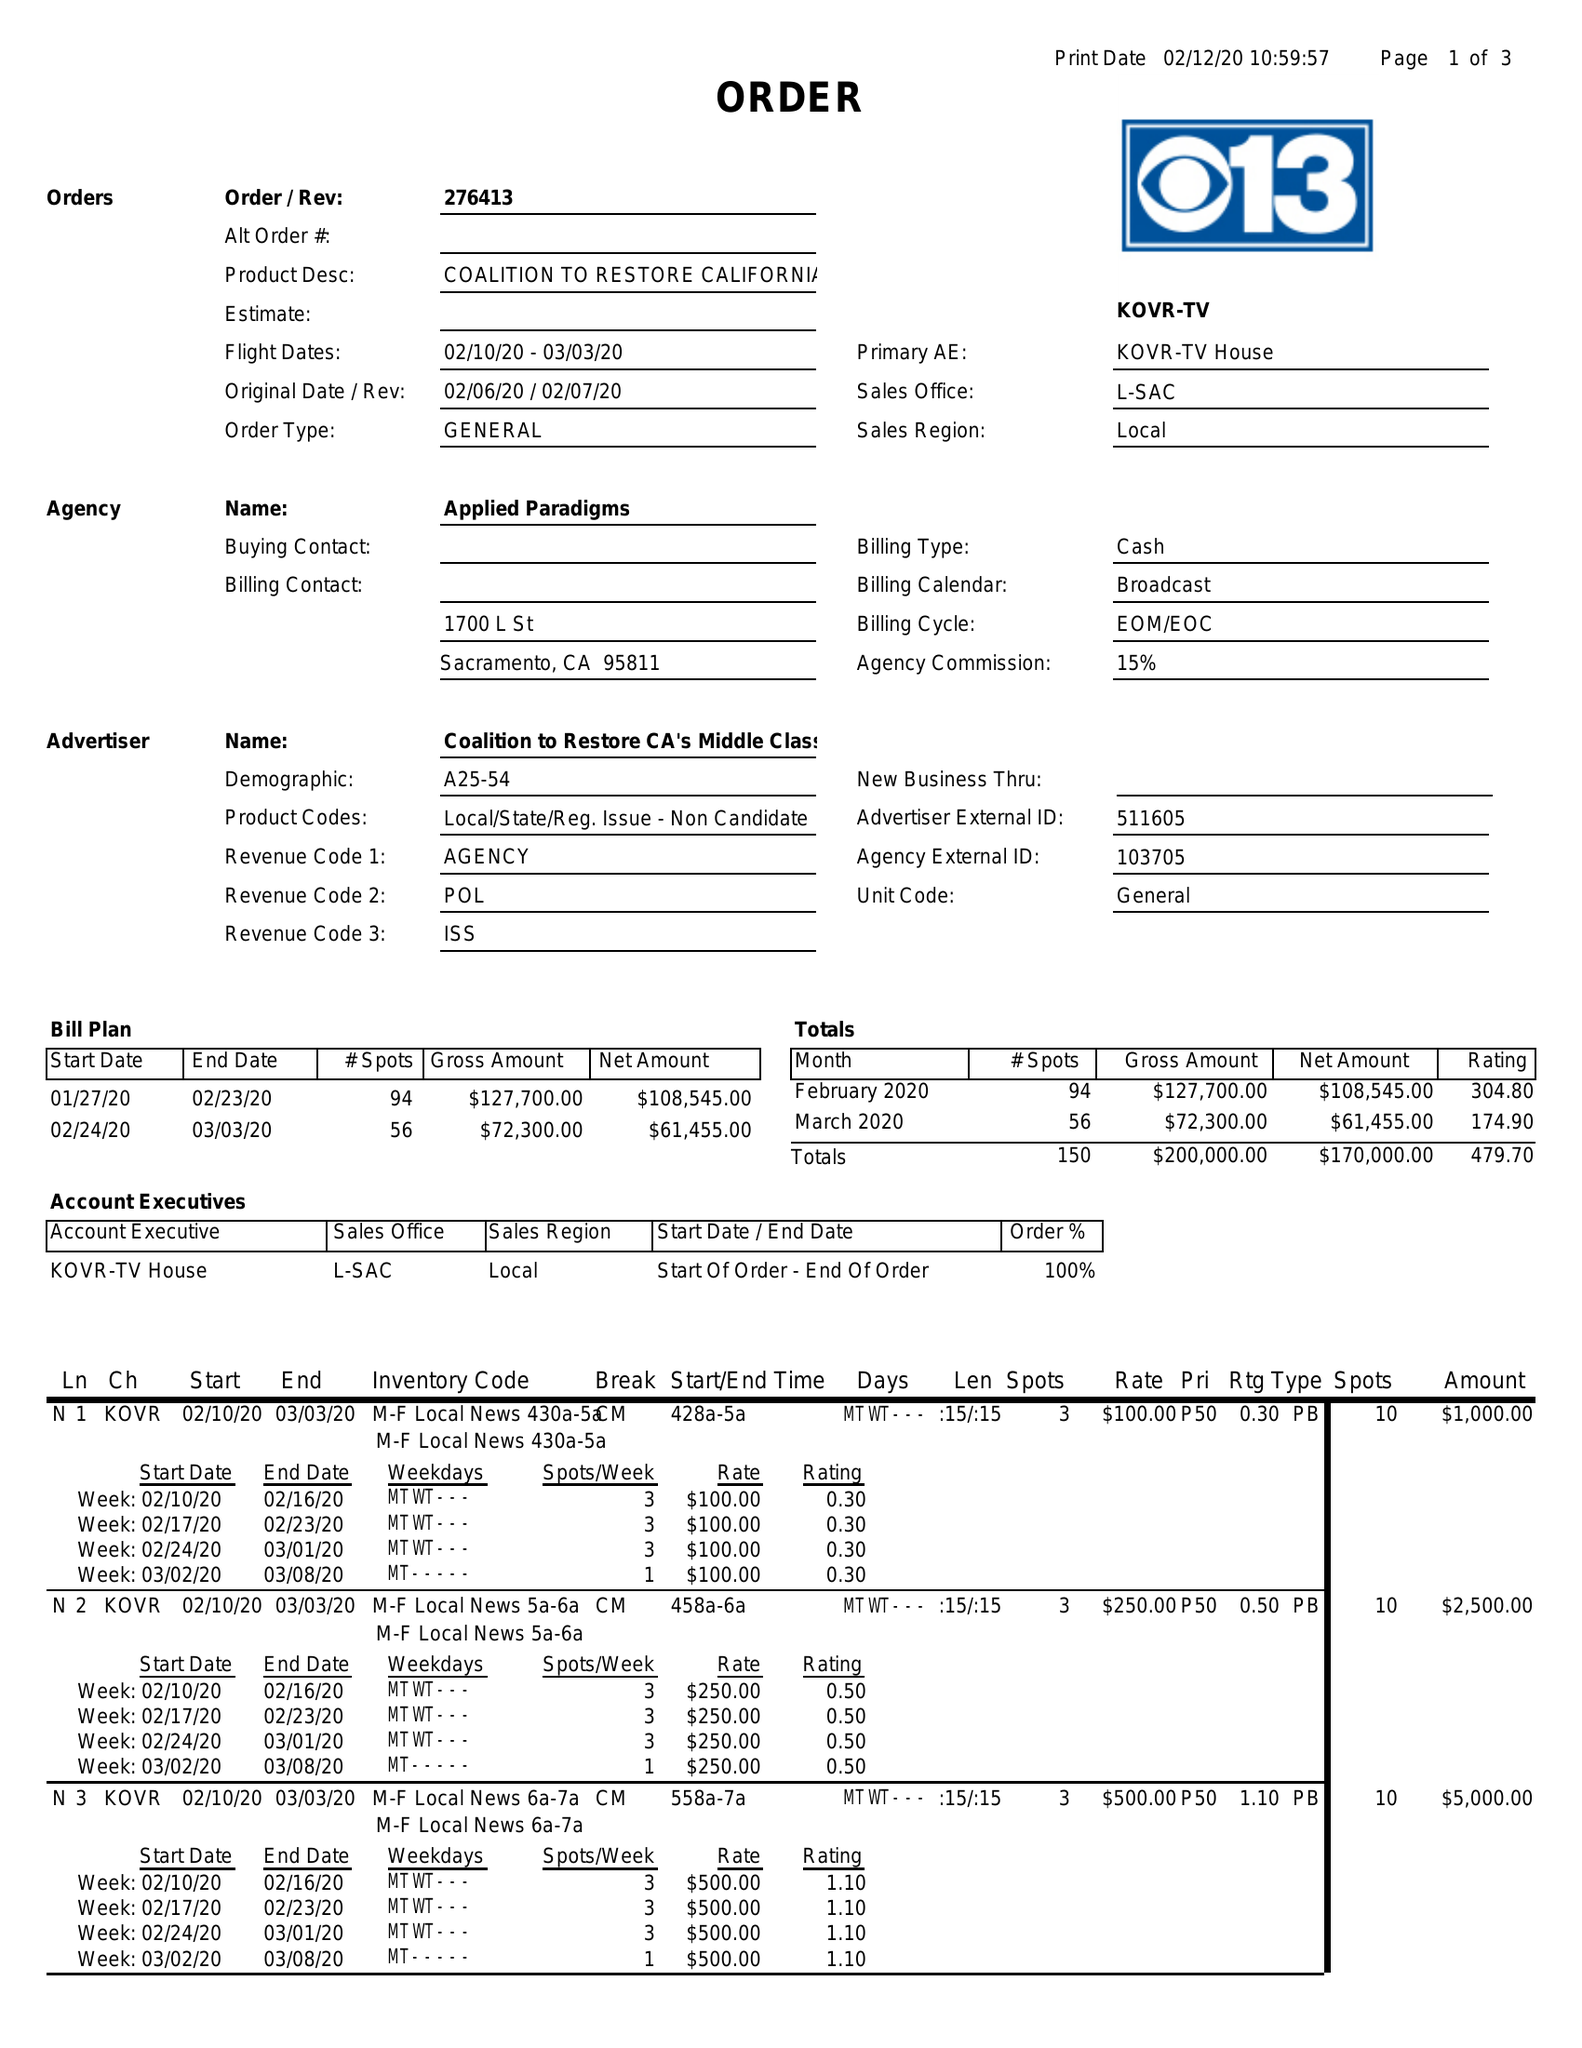What is the value for the advertiser?
Answer the question using a single word or phrase. COALITION TO RESTORE CA'S MIDDLE CLASS 